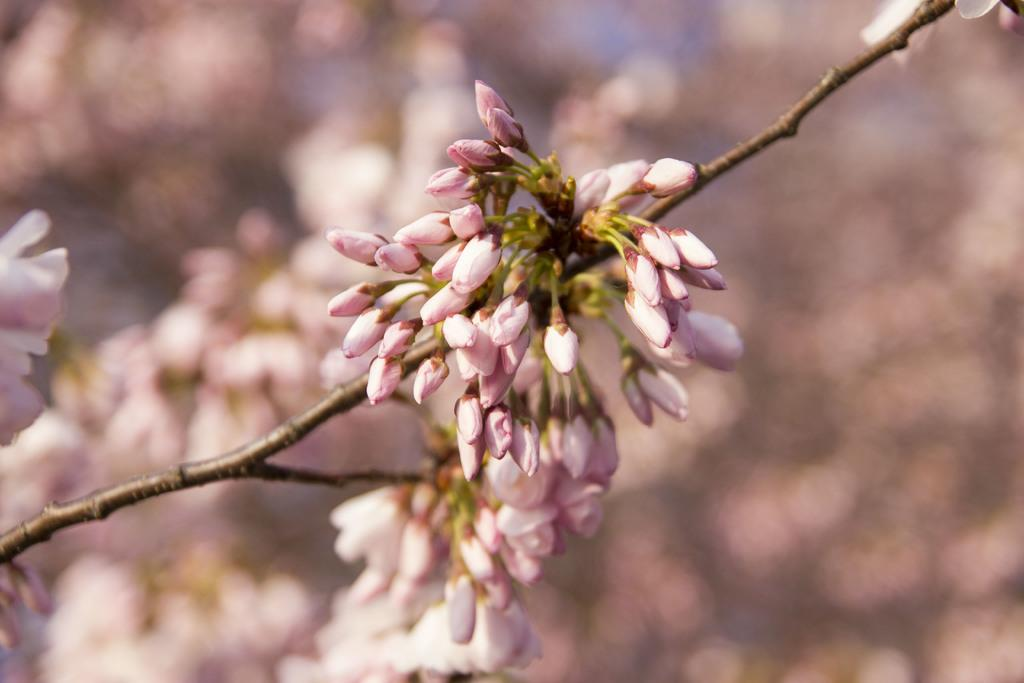What is the main subject of the picture? The main subject of the picture is a branch of a flower plant. What can be observed on the branch? Flower buds are visible on the branch. How many chairs are placed around the flower plant in the image? There are no chairs present in the image; it only features a branch of a flower plant with flower buds. What type of oil is being used to nourish the flower plant in the image? There is no oil visible in the image, and it is not mentioned that any oil is being used to nourish the flower plant. 